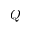<formula> <loc_0><loc_0><loc_500><loc_500>Q</formula> 